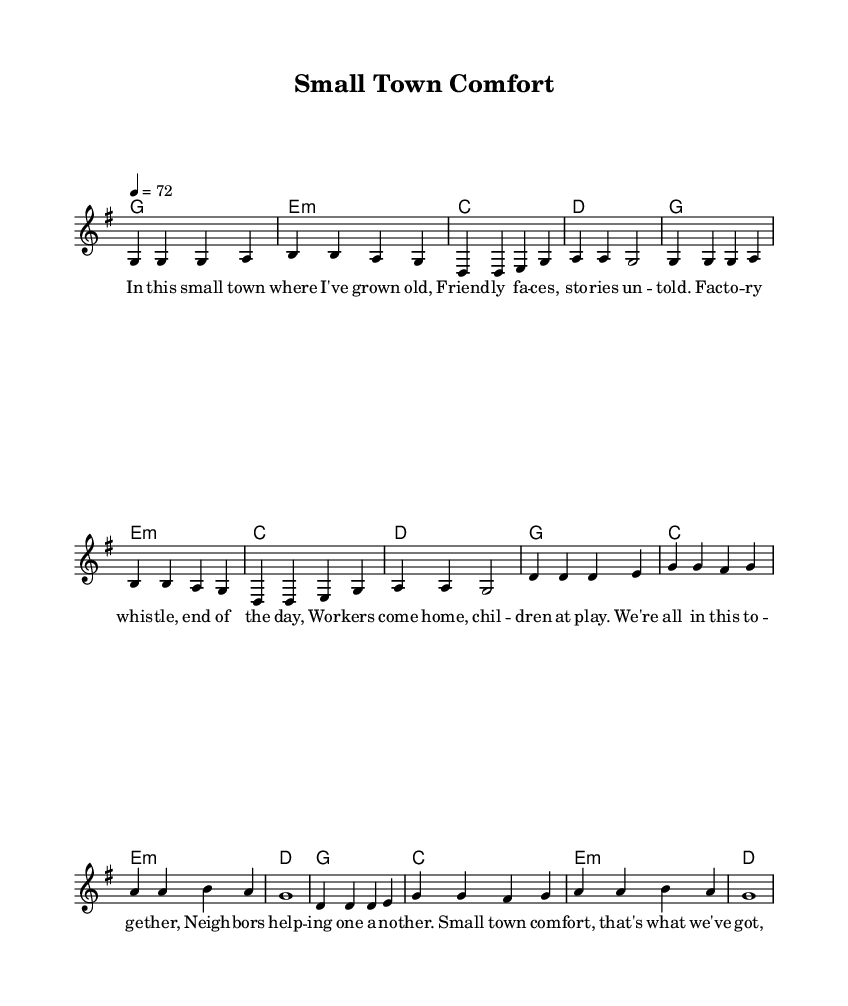What is the key signature of this music? The key signature is indicated at the beginning of the score, and it shows one sharp (F#), which means the music is in G major.
Answer: G major What is the time signature of this music? The time signature is the fraction indicating how many beats are in each measure. It is shown right after the key signature and is noted as 4/4, meaning there are four beats per measure.
Answer: 4/4 What is the tempo of this music? The tempo marking is located above the staff. It indicates that the piece should be played at a speed of 72 beats per minute.
Answer: 72 How many measures are in the verse section? By counting the measures in the notated verse section, we can see that there are eight measures total.
Answer: 8 What is the emotional theme of the chorus lyrics? Analyzing the lyrics of the chorus, we can summarize that the theme revolves around unity and support within a small town community, emphasizing kindness and relationships.
Answer: Unity Which chord is used in the first measure? Referring to the chord symbols above the notation, the first measure has a G major chord, which is represented by G.
Answer: G What is a unique characteristic of Country Rock as seen in this piece? This piece showcases nostalgic themes of small-town life and community in its lyrics and structure, typical of Country Rock music.
Answer: Nostalgic themes 